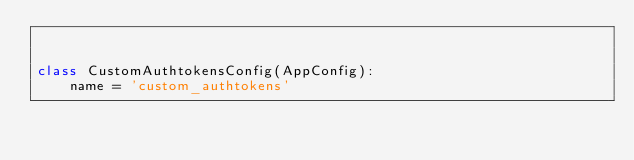Convert code to text. <code><loc_0><loc_0><loc_500><loc_500><_Python_>

class CustomAuthtokensConfig(AppConfig):
    name = 'custom_authtokens'
</code> 